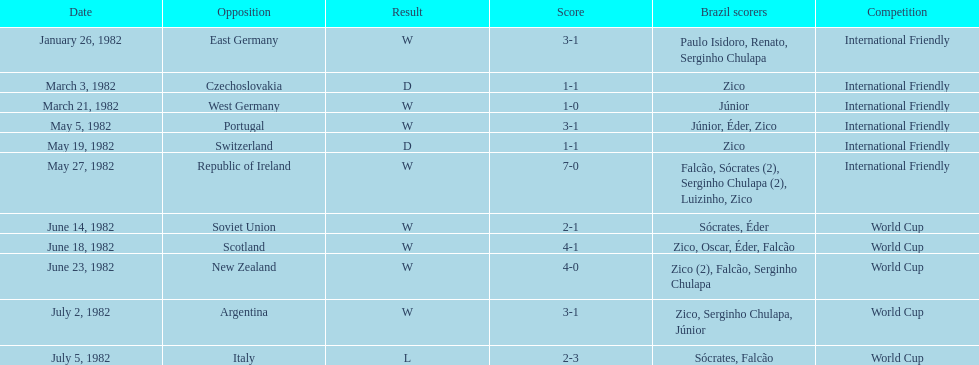What is the number of games won by brazil during the month of march 1982? 1. Can you give me this table as a dict? {'header': ['Date', 'Opposition', 'Result', 'Score', 'Brazil scorers', 'Competition'], 'rows': [['January 26, 1982', 'East Germany', 'W', '3-1', 'Paulo Isidoro, Renato, Serginho Chulapa', 'International Friendly'], ['March 3, 1982', 'Czechoslovakia', 'D', '1-1', 'Zico', 'International Friendly'], ['March 21, 1982', 'West Germany', 'W', '1-0', 'Júnior', 'International Friendly'], ['May 5, 1982', 'Portugal', 'W', '3-1', 'Júnior, Éder, Zico', 'International Friendly'], ['May 19, 1982', 'Switzerland', 'D', '1-1', 'Zico', 'International Friendly'], ['May 27, 1982', 'Republic of Ireland', 'W', '7-0', 'Falcão, Sócrates (2), Serginho Chulapa (2), Luizinho, Zico', 'International Friendly'], ['June 14, 1982', 'Soviet Union', 'W', '2-1', 'Sócrates, Éder', 'World Cup'], ['June 18, 1982', 'Scotland', 'W', '4-1', 'Zico, Oscar, Éder, Falcão', 'World Cup'], ['June 23, 1982', 'New Zealand', 'W', '4-0', 'Zico (2), Falcão, Serginho Chulapa', 'World Cup'], ['July 2, 1982', 'Argentina', 'W', '3-1', 'Zico, Serginho Chulapa, Júnior', 'World Cup'], ['July 5, 1982', 'Italy', 'L', '2-3', 'Sócrates, Falcão', 'World Cup']]} 